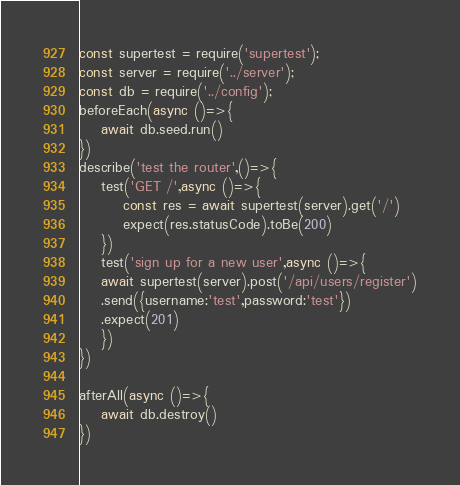Convert code to text. <code><loc_0><loc_0><loc_500><loc_500><_JavaScript_>const supertest = require('supertest');
const server = require('../server');
const db = require('../config');
beforeEach(async ()=>{
    await db.seed.run()
})
describe('test the router',()=>{
    test('GET /',async ()=>{
        const res = await supertest(server).get('/')
        expect(res.statusCode).toBe(200)
    })
    test('sign up for a new user',async ()=>{
    await supertest(server).post('/api/users/register')
    .send({username:'test',password:'test'})
    .expect(201)
    })
})

afterAll(async ()=>{
    await db.destroy()
})</code> 